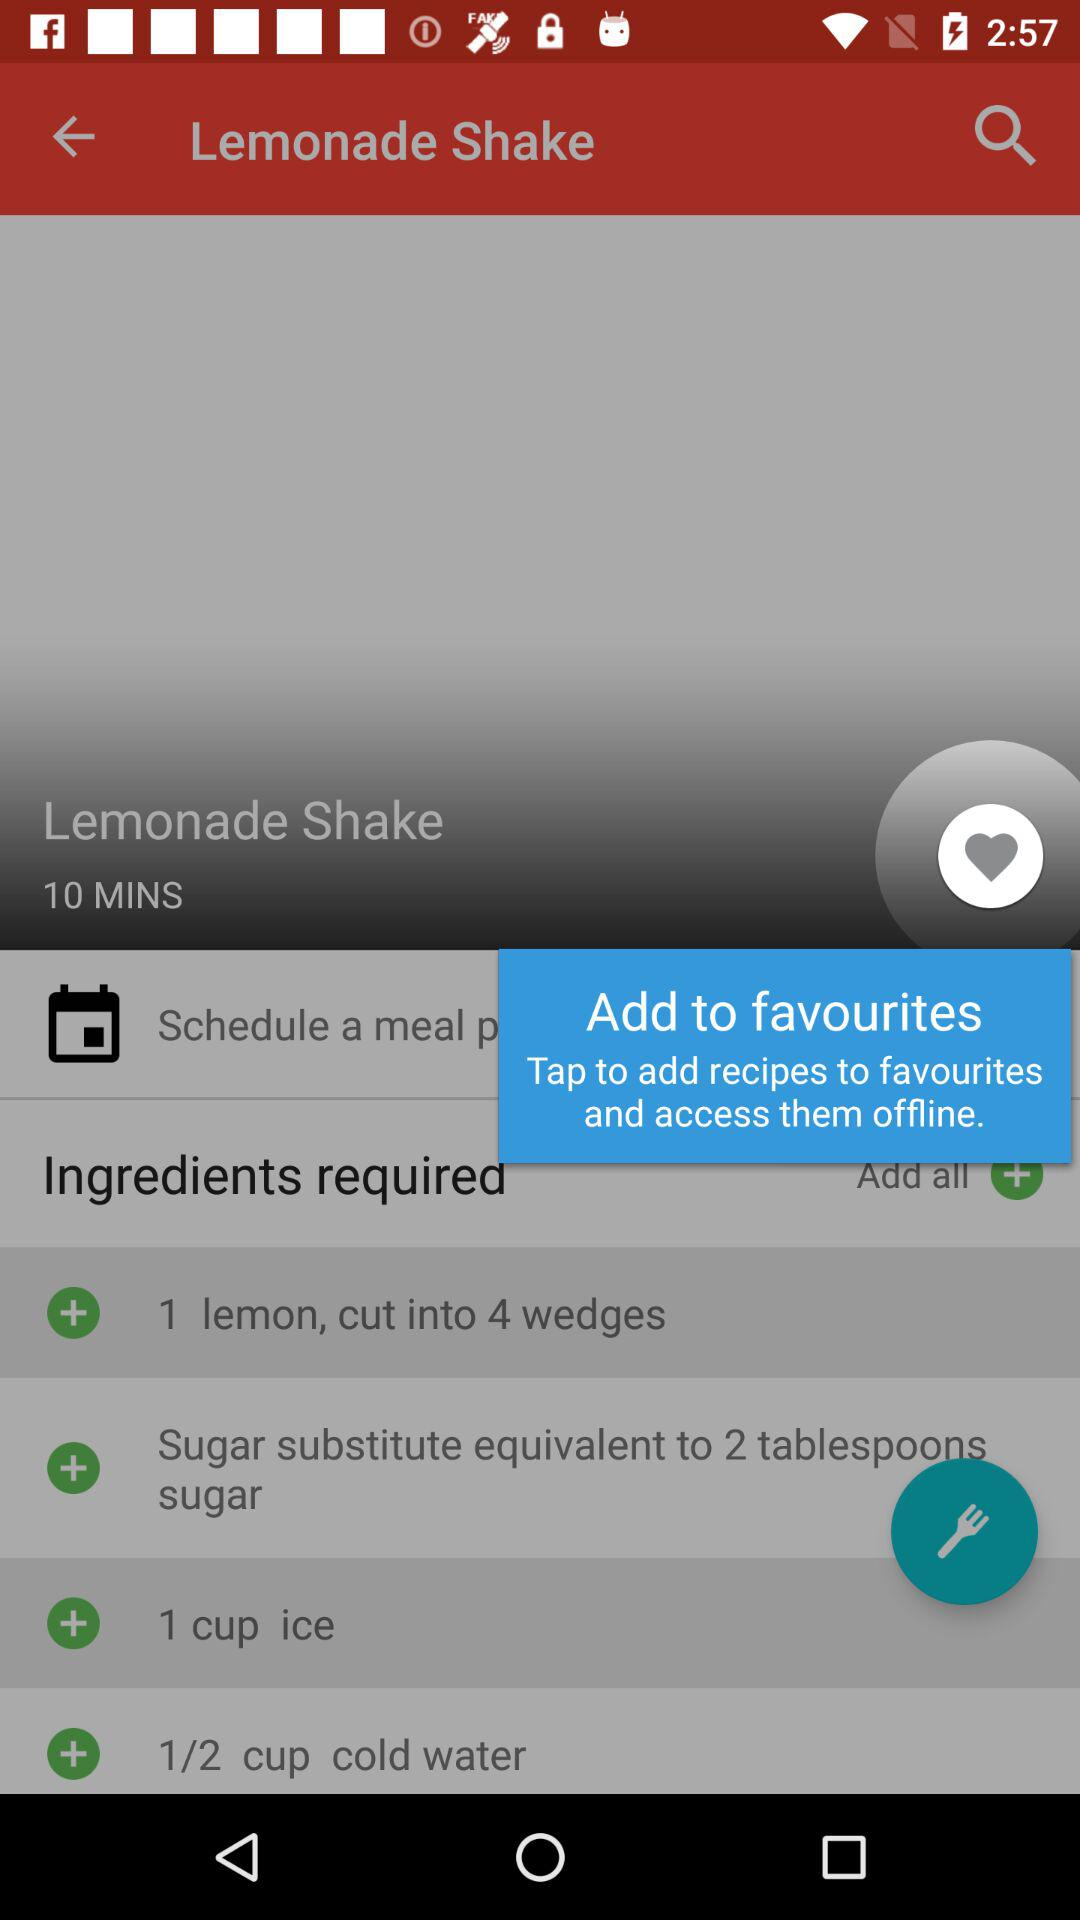How many lemons are required to make "Lemonade Shake"? There is 1 lemon required to make Lemonade shake. 